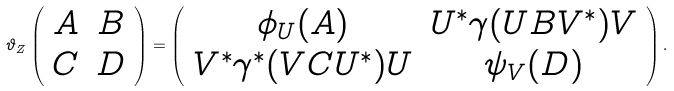Convert formula to latex. <formula><loc_0><loc_0><loc_500><loc_500>\vartheta _ { Z } \left ( \begin{array} { c c } A & B \\ C & D \end{array} \right ) = \left ( \begin{array} { c c } \phi _ { U } ( A ) & U ^ { * } \gamma ( U B V ^ { * } ) V \\ V ^ { * } \gamma ^ { * } ( V C U ^ { * } ) U & \psi _ { V } ( D ) \end{array} \right ) .</formula> 